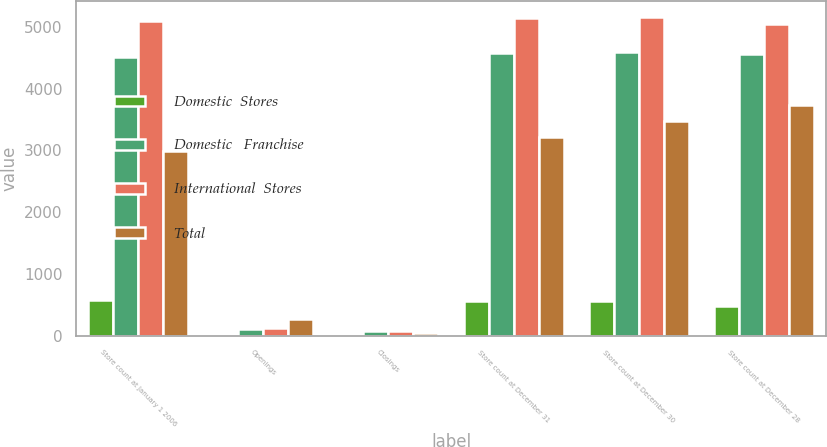Convert chart to OTSL. <chart><loc_0><loc_0><loc_500><loc_500><stacked_bar_chart><ecel><fcel>Store count at January 1 2006<fcel>Openings<fcel>Closings<fcel>Store count at December 31<fcel>Store count at December 30<fcel>Store count at December 28<nl><fcel>Domestic  Stores<fcel>581<fcel>7<fcel>3<fcel>571<fcel>571<fcel>489<nl><fcel>Domestic   Franchise<fcel>4511<fcel>119<fcel>72<fcel>4572<fcel>4584<fcel>4558<nl><fcel>International  Stores<fcel>5092<fcel>126<fcel>75<fcel>5143<fcel>5155<fcel>5047<nl><fcel>Total<fcel>2987<fcel>276<fcel>40<fcel>3223<fcel>3469<fcel>3726<nl></chart> 